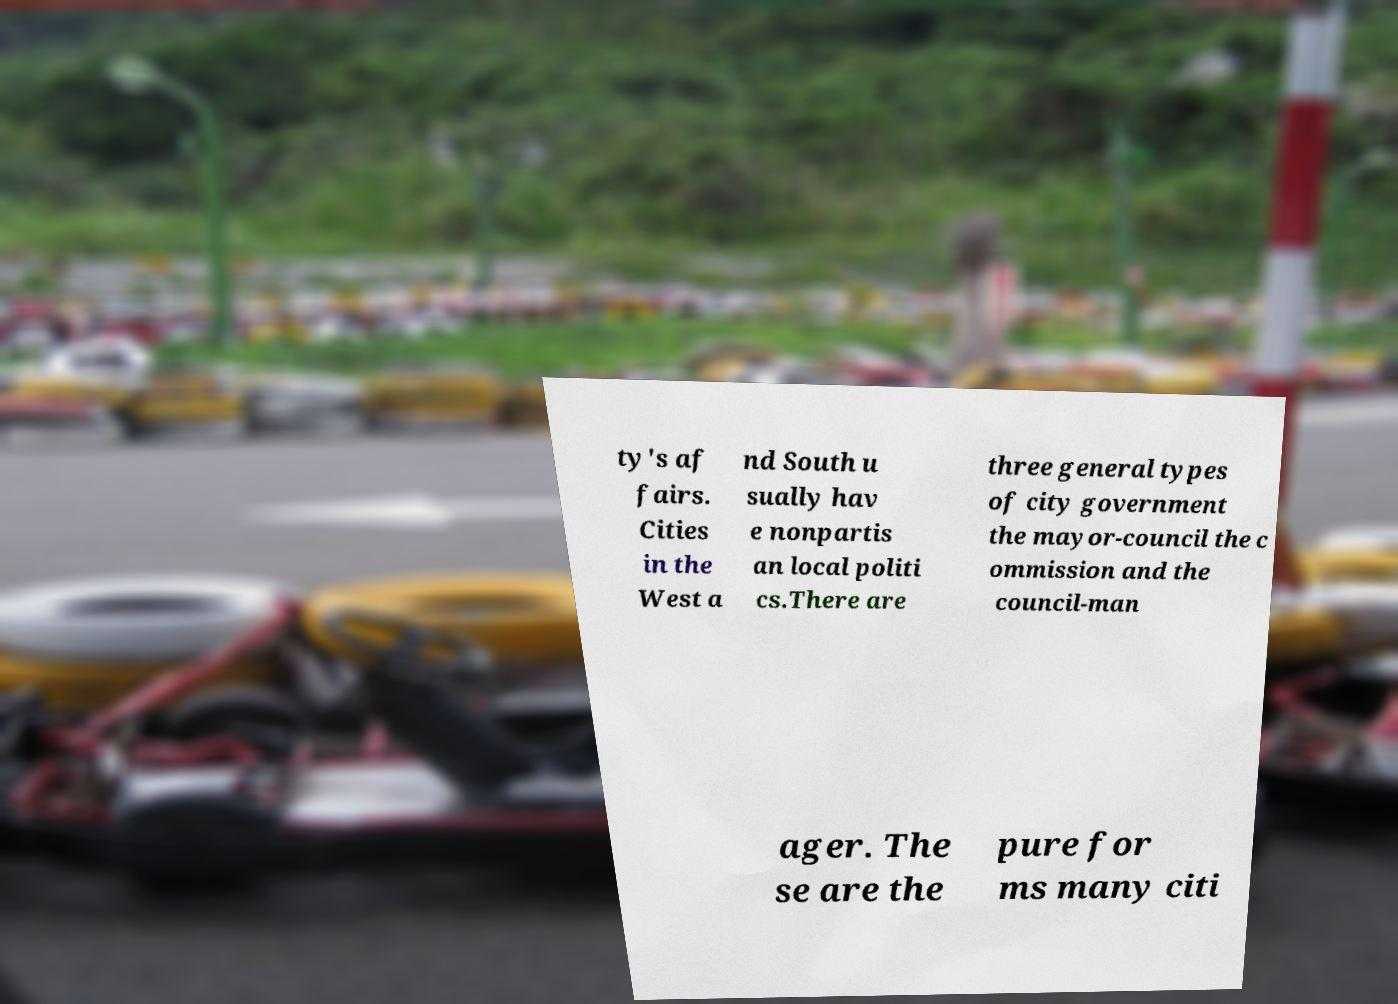There's text embedded in this image that I need extracted. Can you transcribe it verbatim? ty's af fairs. Cities in the West a nd South u sually hav e nonpartis an local politi cs.There are three general types of city government the mayor-council the c ommission and the council-man ager. The se are the pure for ms many citi 